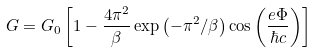<formula> <loc_0><loc_0><loc_500><loc_500>G = G _ { 0 } \left [ 1 - \frac { 4 \pi ^ { 2 } } { \beta } \exp \left ( - \pi ^ { 2 } / \beta \right ) \cos \left ( \frac { e \Phi } { \hbar { c } } \right ) \right ]</formula> 